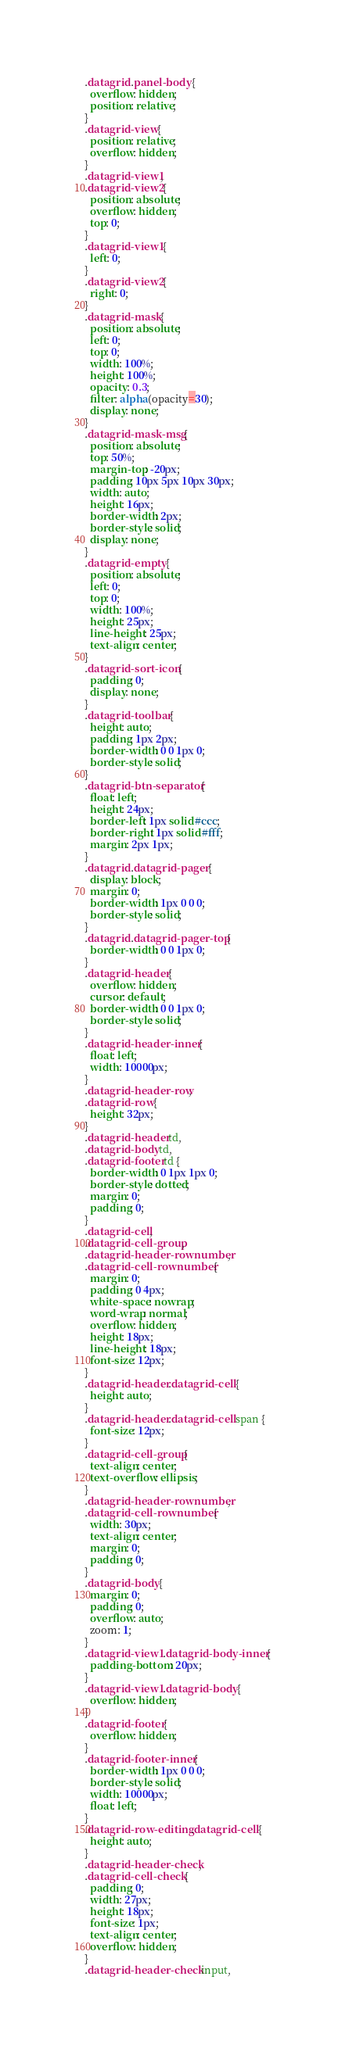Convert code to text. <code><loc_0><loc_0><loc_500><loc_500><_CSS_>.datagrid .panel-body {
  overflow: hidden;
  position: relative;
}
.datagrid-view {
  position: relative;
  overflow: hidden;
}
.datagrid-view1,
.datagrid-view2 {
  position: absolute;
  overflow: hidden;
  top: 0;
}
.datagrid-view1 {
  left: 0;
}
.datagrid-view2 {
  right: 0;
}
.datagrid-mask {
  position: absolute;
  left: 0;
  top: 0;
  width: 100%;
  height: 100%;
  opacity: 0.3;
  filter: alpha(opacity=30);
  display: none;
}
.datagrid-mask-msg {
  position: absolute;
  top: 50%;
  margin-top: -20px;
  padding: 10px 5px 10px 30px;
  width: auto;
  height: 16px;
  border-width: 2px;
  border-style: solid;
  display: none;
}
.datagrid-empty {
  position: absolute;
  left: 0;
  top: 0;
  width: 100%;
  height: 25px;
  line-height: 25px;
  text-align: center;
}
.datagrid-sort-icon {
  padding: 0;
  display: none;
}
.datagrid-toolbar {
  height: auto;
  padding: 1px 2px;
  border-width: 0 0 1px 0;
  border-style: solid;
}
.datagrid-btn-separator {
  float: left;
  height: 24px;
  border-left: 1px solid #ccc;
  border-right: 1px solid #fff;
  margin: 2px 1px;
}
.datagrid .datagrid-pager {
  display: block;
  margin: 0;
  border-width: 1px 0 0 0;
  border-style: solid;
}
.datagrid .datagrid-pager-top {
  border-width: 0 0 1px 0;
}
.datagrid-header {
  overflow: hidden;
  cursor: default;
  border-width: 0 0 1px 0;
  border-style: solid;
}
.datagrid-header-inner {
  float: left;
  width: 10000px;
}
.datagrid-header-row,
.datagrid-row {
  height: 32px;
}
.datagrid-header td,
.datagrid-body td,
.datagrid-footer td {
  border-width: 0 1px 1px 0;
  border-style: dotted;
  margin: 0;
  padding: 0;
}
.datagrid-cell,
.datagrid-cell-group,
.datagrid-header-rownumber,
.datagrid-cell-rownumber {
  margin: 0;
  padding: 0 4px;
  white-space: nowrap;
  word-wrap: normal;
  overflow: hidden;
  height: 18px;
  line-height: 18px;
  font-size: 12px;
}
.datagrid-header .datagrid-cell {
  height: auto;
}
.datagrid-header .datagrid-cell span {
  font-size: 12px;
}
.datagrid-cell-group {
  text-align: center;
  text-overflow: ellipsis;
}
.datagrid-header-rownumber,
.datagrid-cell-rownumber {
  width: 30px;
  text-align: center;
  margin: 0;
  padding: 0;
}
.datagrid-body {
  margin: 0;
  padding: 0;
  overflow: auto;
  zoom: 1;
}
.datagrid-view1 .datagrid-body-inner {
  padding-bottom: 20px;
}
.datagrid-view1 .datagrid-body {
  overflow: hidden;
}
.datagrid-footer {
  overflow: hidden;
}
.datagrid-footer-inner {
  border-width: 1px 0 0 0;
  border-style: solid;
  width: 10000px;
  float: left;
}
.datagrid-row-editing .datagrid-cell {
  height: auto;
}
.datagrid-header-check,
.datagrid-cell-check {
  padding: 0;
  width: 27px;
  height: 18px;
  font-size: 1px;
  text-align: center;
  overflow: hidden;
}
.datagrid-header-check input,</code> 